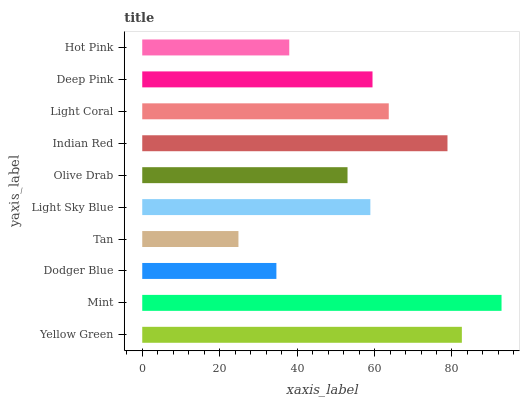Is Tan the minimum?
Answer yes or no. Yes. Is Mint the maximum?
Answer yes or no. Yes. Is Dodger Blue the minimum?
Answer yes or no. No. Is Dodger Blue the maximum?
Answer yes or no. No. Is Mint greater than Dodger Blue?
Answer yes or no. Yes. Is Dodger Blue less than Mint?
Answer yes or no. Yes. Is Dodger Blue greater than Mint?
Answer yes or no. No. Is Mint less than Dodger Blue?
Answer yes or no. No. Is Deep Pink the high median?
Answer yes or no. Yes. Is Light Sky Blue the low median?
Answer yes or no. Yes. Is Olive Drab the high median?
Answer yes or no. No. Is Yellow Green the low median?
Answer yes or no. No. 